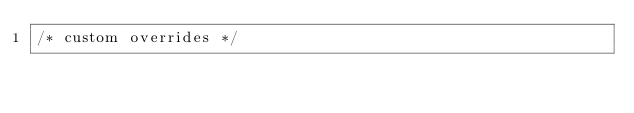<code> <loc_0><loc_0><loc_500><loc_500><_CSS_>/* custom overrides */
</code> 